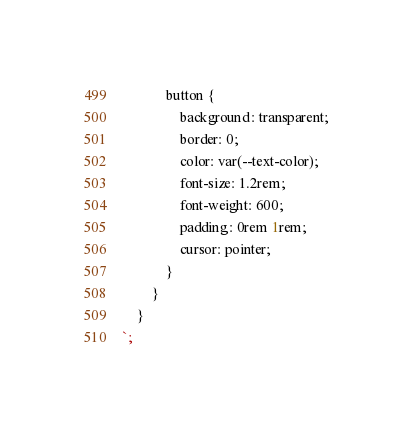Convert code to text. <code><loc_0><loc_0><loc_500><loc_500><_TypeScript_>            button {
                background: transparent;
                border: 0;
                color: var(--text-color);
                font-size: 1.2rem;
                font-weight: 600;
                padding: 0rem 1rem;
                cursor: pointer;
            }
        }        
    }
`;</code> 